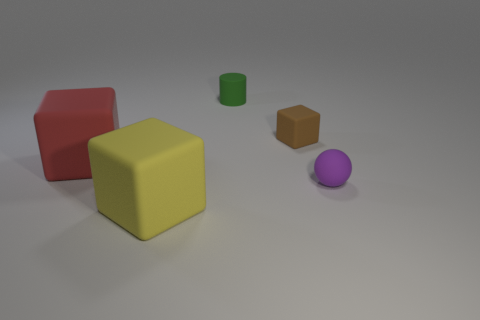How many balls are the same color as the rubber cylinder?
Ensure brevity in your answer.  0. Is there anything else that is the same shape as the red rubber thing?
Make the answer very short. Yes. There is a big matte block that is left of the block in front of the red rubber block; are there any objects that are on the right side of it?
Provide a succinct answer. Yes. How many yellow things have the same material as the purple thing?
Your answer should be compact. 1. There is a rubber block to the right of the small matte cylinder; is it the same size as the green cylinder behind the yellow rubber cube?
Your answer should be very brief. Yes. There is a block that is in front of the large matte object that is behind the rubber object that is right of the small brown matte block; what color is it?
Provide a short and direct response. Yellow. Is there a big blue matte thing that has the same shape as the tiny purple matte thing?
Your answer should be compact. No. Are there the same number of objects left of the rubber sphere and brown things in front of the green rubber thing?
Your answer should be very brief. No. Does the tiny object that is in front of the red thing have the same shape as the red object?
Your response must be concise. No. Do the yellow rubber thing and the red thing have the same shape?
Give a very brief answer. Yes. 